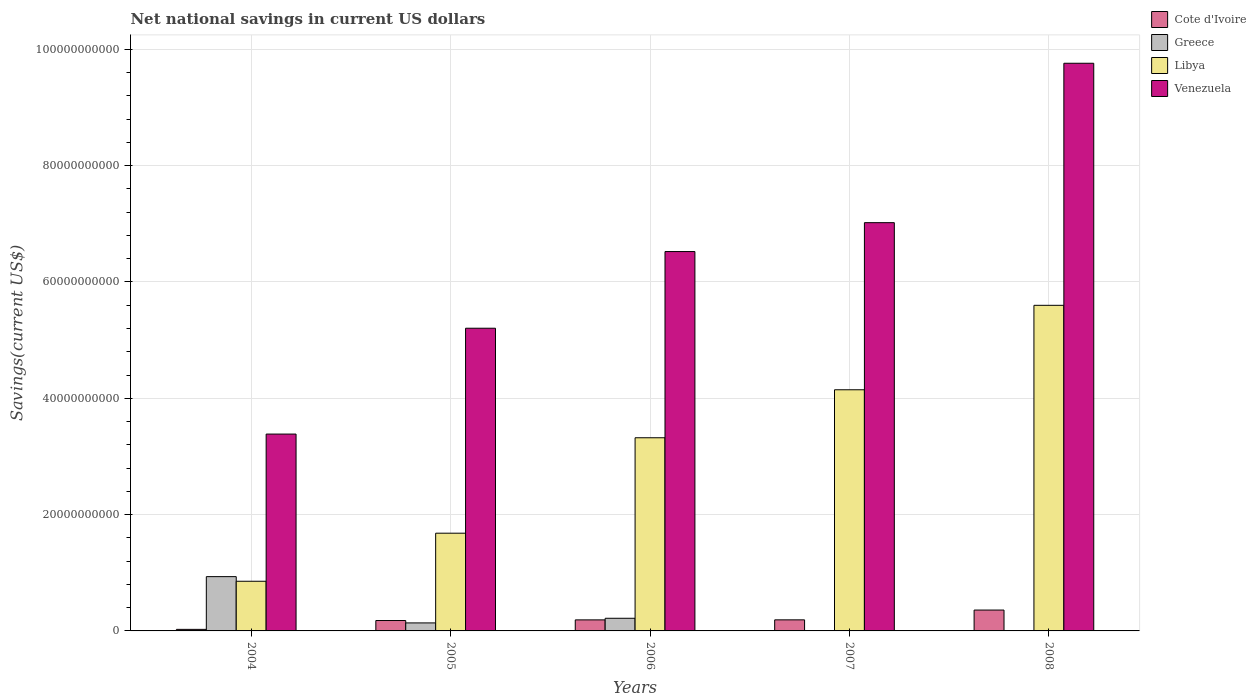How many different coloured bars are there?
Keep it short and to the point. 4. How many groups of bars are there?
Your answer should be very brief. 5. Are the number of bars per tick equal to the number of legend labels?
Keep it short and to the point. No. How many bars are there on the 4th tick from the left?
Offer a very short reply. 3. How many bars are there on the 4th tick from the right?
Your answer should be very brief. 4. What is the net national savings in Venezuela in 2007?
Keep it short and to the point. 7.02e+1. Across all years, what is the maximum net national savings in Greece?
Offer a terse response. 9.34e+09. Across all years, what is the minimum net national savings in Cote d'Ivoire?
Give a very brief answer. 2.67e+08. What is the total net national savings in Greece in the graph?
Ensure brevity in your answer.  1.29e+1. What is the difference between the net national savings in Libya in 2005 and that in 2006?
Provide a short and direct response. -1.64e+1. What is the difference between the net national savings in Venezuela in 2007 and the net national savings in Greece in 2005?
Provide a succinct answer. 6.88e+1. What is the average net national savings in Venezuela per year?
Make the answer very short. 6.38e+1. In the year 2007, what is the difference between the net national savings in Libya and net national savings in Cote d'Ivoire?
Keep it short and to the point. 3.96e+1. In how many years, is the net national savings in Greece greater than 52000000000 US$?
Provide a succinct answer. 0. What is the ratio of the net national savings in Venezuela in 2005 to that in 2008?
Keep it short and to the point. 0.53. Is the net national savings in Libya in 2006 less than that in 2008?
Make the answer very short. Yes. What is the difference between the highest and the second highest net national savings in Greece?
Offer a very short reply. 7.16e+09. What is the difference between the highest and the lowest net national savings in Venezuela?
Your answer should be compact. 6.38e+1. Is the sum of the net national savings in Libya in 2007 and 2008 greater than the maximum net national savings in Cote d'Ivoire across all years?
Provide a short and direct response. Yes. Is it the case that in every year, the sum of the net national savings in Cote d'Ivoire and net national savings in Libya is greater than the sum of net national savings in Greece and net national savings in Venezuela?
Make the answer very short. Yes. Is it the case that in every year, the sum of the net national savings in Libya and net national savings in Greece is greater than the net national savings in Venezuela?
Provide a succinct answer. No. Are all the bars in the graph horizontal?
Keep it short and to the point. No. How many years are there in the graph?
Give a very brief answer. 5. What is the difference between two consecutive major ticks on the Y-axis?
Offer a terse response. 2.00e+1. Are the values on the major ticks of Y-axis written in scientific E-notation?
Provide a short and direct response. No. Does the graph contain any zero values?
Give a very brief answer. Yes. Does the graph contain grids?
Give a very brief answer. Yes. Where does the legend appear in the graph?
Give a very brief answer. Top right. How many legend labels are there?
Provide a short and direct response. 4. What is the title of the graph?
Make the answer very short. Net national savings in current US dollars. What is the label or title of the X-axis?
Your response must be concise. Years. What is the label or title of the Y-axis?
Keep it short and to the point. Savings(current US$). What is the Savings(current US$) in Cote d'Ivoire in 2004?
Give a very brief answer. 2.67e+08. What is the Savings(current US$) in Greece in 2004?
Make the answer very short. 9.34e+09. What is the Savings(current US$) in Libya in 2004?
Provide a short and direct response. 8.54e+09. What is the Savings(current US$) in Venezuela in 2004?
Your response must be concise. 3.39e+1. What is the Savings(current US$) of Cote d'Ivoire in 2005?
Make the answer very short. 1.79e+09. What is the Savings(current US$) of Greece in 2005?
Offer a very short reply. 1.38e+09. What is the Savings(current US$) in Libya in 2005?
Give a very brief answer. 1.68e+1. What is the Savings(current US$) in Venezuela in 2005?
Ensure brevity in your answer.  5.20e+1. What is the Savings(current US$) of Cote d'Ivoire in 2006?
Ensure brevity in your answer.  1.90e+09. What is the Savings(current US$) of Greece in 2006?
Provide a succinct answer. 2.17e+09. What is the Savings(current US$) in Libya in 2006?
Your answer should be very brief. 3.32e+1. What is the Savings(current US$) in Venezuela in 2006?
Provide a succinct answer. 6.52e+1. What is the Savings(current US$) of Cote d'Ivoire in 2007?
Your answer should be very brief. 1.90e+09. What is the Savings(current US$) of Libya in 2007?
Provide a short and direct response. 4.15e+1. What is the Savings(current US$) in Venezuela in 2007?
Your answer should be compact. 7.02e+1. What is the Savings(current US$) of Cote d'Ivoire in 2008?
Give a very brief answer. 3.59e+09. What is the Savings(current US$) in Libya in 2008?
Your answer should be compact. 5.60e+1. What is the Savings(current US$) in Venezuela in 2008?
Provide a succinct answer. 9.76e+1. Across all years, what is the maximum Savings(current US$) of Cote d'Ivoire?
Provide a short and direct response. 3.59e+09. Across all years, what is the maximum Savings(current US$) in Greece?
Ensure brevity in your answer.  9.34e+09. Across all years, what is the maximum Savings(current US$) in Libya?
Your response must be concise. 5.60e+1. Across all years, what is the maximum Savings(current US$) in Venezuela?
Offer a very short reply. 9.76e+1. Across all years, what is the minimum Savings(current US$) of Cote d'Ivoire?
Offer a very short reply. 2.67e+08. Across all years, what is the minimum Savings(current US$) in Libya?
Make the answer very short. 8.54e+09. Across all years, what is the minimum Savings(current US$) in Venezuela?
Your response must be concise. 3.39e+1. What is the total Savings(current US$) in Cote d'Ivoire in the graph?
Your answer should be very brief. 9.45e+09. What is the total Savings(current US$) of Greece in the graph?
Ensure brevity in your answer.  1.29e+1. What is the total Savings(current US$) of Libya in the graph?
Provide a short and direct response. 1.56e+11. What is the total Savings(current US$) of Venezuela in the graph?
Keep it short and to the point. 3.19e+11. What is the difference between the Savings(current US$) in Cote d'Ivoire in 2004 and that in 2005?
Provide a succinct answer. -1.52e+09. What is the difference between the Savings(current US$) of Greece in 2004 and that in 2005?
Provide a succinct answer. 7.96e+09. What is the difference between the Savings(current US$) in Libya in 2004 and that in 2005?
Offer a terse response. -8.26e+09. What is the difference between the Savings(current US$) in Venezuela in 2004 and that in 2005?
Ensure brevity in your answer.  -1.82e+1. What is the difference between the Savings(current US$) of Cote d'Ivoire in 2004 and that in 2006?
Provide a succinct answer. -1.63e+09. What is the difference between the Savings(current US$) in Greece in 2004 and that in 2006?
Give a very brief answer. 7.16e+09. What is the difference between the Savings(current US$) of Libya in 2004 and that in 2006?
Provide a succinct answer. -2.47e+1. What is the difference between the Savings(current US$) of Venezuela in 2004 and that in 2006?
Offer a terse response. -3.14e+1. What is the difference between the Savings(current US$) in Cote d'Ivoire in 2004 and that in 2007?
Provide a succinct answer. -1.64e+09. What is the difference between the Savings(current US$) in Libya in 2004 and that in 2007?
Give a very brief answer. -3.29e+1. What is the difference between the Savings(current US$) of Venezuela in 2004 and that in 2007?
Offer a very short reply. -3.64e+1. What is the difference between the Savings(current US$) in Cote d'Ivoire in 2004 and that in 2008?
Your answer should be very brief. -3.32e+09. What is the difference between the Savings(current US$) of Libya in 2004 and that in 2008?
Offer a terse response. -4.74e+1. What is the difference between the Savings(current US$) in Venezuela in 2004 and that in 2008?
Offer a terse response. -6.38e+1. What is the difference between the Savings(current US$) in Cote d'Ivoire in 2005 and that in 2006?
Provide a short and direct response. -1.12e+08. What is the difference between the Savings(current US$) of Greece in 2005 and that in 2006?
Keep it short and to the point. -7.96e+08. What is the difference between the Savings(current US$) in Libya in 2005 and that in 2006?
Make the answer very short. -1.64e+1. What is the difference between the Savings(current US$) of Venezuela in 2005 and that in 2006?
Give a very brief answer. -1.32e+1. What is the difference between the Savings(current US$) in Cote d'Ivoire in 2005 and that in 2007?
Offer a terse response. -1.17e+08. What is the difference between the Savings(current US$) in Libya in 2005 and that in 2007?
Your answer should be compact. -2.47e+1. What is the difference between the Savings(current US$) in Venezuela in 2005 and that in 2007?
Give a very brief answer. -1.82e+1. What is the difference between the Savings(current US$) in Cote d'Ivoire in 2005 and that in 2008?
Ensure brevity in your answer.  -1.80e+09. What is the difference between the Savings(current US$) in Libya in 2005 and that in 2008?
Your answer should be very brief. -3.92e+1. What is the difference between the Savings(current US$) in Venezuela in 2005 and that in 2008?
Keep it short and to the point. -4.56e+1. What is the difference between the Savings(current US$) of Cote d'Ivoire in 2006 and that in 2007?
Provide a succinct answer. -4.95e+06. What is the difference between the Savings(current US$) in Libya in 2006 and that in 2007?
Your answer should be very brief. -8.25e+09. What is the difference between the Savings(current US$) in Venezuela in 2006 and that in 2007?
Offer a terse response. -4.97e+09. What is the difference between the Savings(current US$) in Cote d'Ivoire in 2006 and that in 2008?
Keep it short and to the point. -1.69e+09. What is the difference between the Savings(current US$) of Libya in 2006 and that in 2008?
Provide a short and direct response. -2.28e+1. What is the difference between the Savings(current US$) in Venezuela in 2006 and that in 2008?
Your answer should be very brief. -3.24e+1. What is the difference between the Savings(current US$) of Cote d'Ivoire in 2007 and that in 2008?
Your answer should be very brief. -1.68e+09. What is the difference between the Savings(current US$) of Libya in 2007 and that in 2008?
Make the answer very short. -1.45e+1. What is the difference between the Savings(current US$) in Venezuela in 2007 and that in 2008?
Offer a terse response. -2.74e+1. What is the difference between the Savings(current US$) in Cote d'Ivoire in 2004 and the Savings(current US$) in Greece in 2005?
Offer a terse response. -1.11e+09. What is the difference between the Savings(current US$) of Cote d'Ivoire in 2004 and the Savings(current US$) of Libya in 2005?
Make the answer very short. -1.65e+1. What is the difference between the Savings(current US$) of Cote d'Ivoire in 2004 and the Savings(current US$) of Venezuela in 2005?
Keep it short and to the point. -5.18e+1. What is the difference between the Savings(current US$) in Greece in 2004 and the Savings(current US$) in Libya in 2005?
Make the answer very short. -7.47e+09. What is the difference between the Savings(current US$) of Greece in 2004 and the Savings(current US$) of Venezuela in 2005?
Provide a succinct answer. -4.27e+1. What is the difference between the Savings(current US$) of Libya in 2004 and the Savings(current US$) of Venezuela in 2005?
Provide a short and direct response. -4.35e+1. What is the difference between the Savings(current US$) in Cote d'Ivoire in 2004 and the Savings(current US$) in Greece in 2006?
Give a very brief answer. -1.91e+09. What is the difference between the Savings(current US$) in Cote d'Ivoire in 2004 and the Savings(current US$) in Libya in 2006?
Your answer should be compact. -3.29e+1. What is the difference between the Savings(current US$) in Cote d'Ivoire in 2004 and the Savings(current US$) in Venezuela in 2006?
Provide a short and direct response. -6.50e+1. What is the difference between the Savings(current US$) in Greece in 2004 and the Savings(current US$) in Libya in 2006?
Offer a terse response. -2.39e+1. What is the difference between the Savings(current US$) of Greece in 2004 and the Savings(current US$) of Venezuela in 2006?
Your answer should be compact. -5.59e+1. What is the difference between the Savings(current US$) in Libya in 2004 and the Savings(current US$) in Venezuela in 2006?
Make the answer very short. -5.67e+1. What is the difference between the Savings(current US$) in Cote d'Ivoire in 2004 and the Savings(current US$) in Libya in 2007?
Provide a succinct answer. -4.12e+1. What is the difference between the Savings(current US$) of Cote d'Ivoire in 2004 and the Savings(current US$) of Venezuela in 2007?
Ensure brevity in your answer.  -6.99e+1. What is the difference between the Savings(current US$) in Greece in 2004 and the Savings(current US$) in Libya in 2007?
Your answer should be very brief. -3.21e+1. What is the difference between the Savings(current US$) in Greece in 2004 and the Savings(current US$) in Venezuela in 2007?
Give a very brief answer. -6.09e+1. What is the difference between the Savings(current US$) of Libya in 2004 and the Savings(current US$) of Venezuela in 2007?
Offer a very short reply. -6.17e+1. What is the difference between the Savings(current US$) of Cote d'Ivoire in 2004 and the Savings(current US$) of Libya in 2008?
Provide a succinct answer. -5.57e+1. What is the difference between the Savings(current US$) of Cote d'Ivoire in 2004 and the Savings(current US$) of Venezuela in 2008?
Your answer should be very brief. -9.73e+1. What is the difference between the Savings(current US$) in Greece in 2004 and the Savings(current US$) in Libya in 2008?
Provide a succinct answer. -4.67e+1. What is the difference between the Savings(current US$) in Greece in 2004 and the Savings(current US$) in Venezuela in 2008?
Your answer should be compact. -8.83e+1. What is the difference between the Savings(current US$) of Libya in 2004 and the Savings(current US$) of Venezuela in 2008?
Offer a very short reply. -8.91e+1. What is the difference between the Savings(current US$) in Cote d'Ivoire in 2005 and the Savings(current US$) in Greece in 2006?
Give a very brief answer. -3.87e+08. What is the difference between the Savings(current US$) in Cote d'Ivoire in 2005 and the Savings(current US$) in Libya in 2006?
Keep it short and to the point. -3.14e+1. What is the difference between the Savings(current US$) of Cote d'Ivoire in 2005 and the Savings(current US$) of Venezuela in 2006?
Your response must be concise. -6.34e+1. What is the difference between the Savings(current US$) in Greece in 2005 and the Savings(current US$) in Libya in 2006?
Provide a short and direct response. -3.18e+1. What is the difference between the Savings(current US$) of Greece in 2005 and the Savings(current US$) of Venezuela in 2006?
Offer a terse response. -6.39e+1. What is the difference between the Savings(current US$) of Libya in 2005 and the Savings(current US$) of Venezuela in 2006?
Your answer should be very brief. -4.84e+1. What is the difference between the Savings(current US$) in Cote d'Ivoire in 2005 and the Savings(current US$) in Libya in 2007?
Ensure brevity in your answer.  -3.97e+1. What is the difference between the Savings(current US$) of Cote d'Ivoire in 2005 and the Savings(current US$) of Venezuela in 2007?
Give a very brief answer. -6.84e+1. What is the difference between the Savings(current US$) of Greece in 2005 and the Savings(current US$) of Libya in 2007?
Your answer should be very brief. -4.01e+1. What is the difference between the Savings(current US$) of Greece in 2005 and the Savings(current US$) of Venezuela in 2007?
Make the answer very short. -6.88e+1. What is the difference between the Savings(current US$) in Libya in 2005 and the Savings(current US$) in Venezuela in 2007?
Give a very brief answer. -5.34e+1. What is the difference between the Savings(current US$) in Cote d'Ivoire in 2005 and the Savings(current US$) in Libya in 2008?
Ensure brevity in your answer.  -5.42e+1. What is the difference between the Savings(current US$) of Cote d'Ivoire in 2005 and the Savings(current US$) of Venezuela in 2008?
Offer a terse response. -9.58e+1. What is the difference between the Savings(current US$) in Greece in 2005 and the Savings(current US$) in Libya in 2008?
Provide a succinct answer. -5.46e+1. What is the difference between the Savings(current US$) of Greece in 2005 and the Savings(current US$) of Venezuela in 2008?
Your answer should be very brief. -9.62e+1. What is the difference between the Savings(current US$) in Libya in 2005 and the Savings(current US$) in Venezuela in 2008?
Offer a terse response. -8.08e+1. What is the difference between the Savings(current US$) in Cote d'Ivoire in 2006 and the Savings(current US$) in Libya in 2007?
Your answer should be compact. -3.96e+1. What is the difference between the Savings(current US$) in Cote d'Ivoire in 2006 and the Savings(current US$) in Venezuela in 2007?
Keep it short and to the point. -6.83e+1. What is the difference between the Savings(current US$) in Greece in 2006 and the Savings(current US$) in Libya in 2007?
Give a very brief answer. -3.93e+1. What is the difference between the Savings(current US$) of Greece in 2006 and the Savings(current US$) of Venezuela in 2007?
Provide a short and direct response. -6.80e+1. What is the difference between the Savings(current US$) in Libya in 2006 and the Savings(current US$) in Venezuela in 2007?
Ensure brevity in your answer.  -3.70e+1. What is the difference between the Savings(current US$) in Cote d'Ivoire in 2006 and the Savings(current US$) in Libya in 2008?
Provide a short and direct response. -5.41e+1. What is the difference between the Savings(current US$) of Cote d'Ivoire in 2006 and the Savings(current US$) of Venezuela in 2008?
Your answer should be very brief. -9.57e+1. What is the difference between the Savings(current US$) in Greece in 2006 and the Savings(current US$) in Libya in 2008?
Provide a succinct answer. -5.38e+1. What is the difference between the Savings(current US$) of Greece in 2006 and the Savings(current US$) of Venezuela in 2008?
Provide a succinct answer. -9.54e+1. What is the difference between the Savings(current US$) in Libya in 2006 and the Savings(current US$) in Venezuela in 2008?
Your answer should be compact. -6.44e+1. What is the difference between the Savings(current US$) of Cote d'Ivoire in 2007 and the Savings(current US$) of Libya in 2008?
Your answer should be very brief. -5.41e+1. What is the difference between the Savings(current US$) of Cote d'Ivoire in 2007 and the Savings(current US$) of Venezuela in 2008?
Your answer should be very brief. -9.57e+1. What is the difference between the Savings(current US$) of Libya in 2007 and the Savings(current US$) of Venezuela in 2008?
Your answer should be compact. -5.61e+1. What is the average Savings(current US$) in Cote d'Ivoire per year?
Give a very brief answer. 1.89e+09. What is the average Savings(current US$) of Greece per year?
Provide a short and direct response. 2.58e+09. What is the average Savings(current US$) of Libya per year?
Ensure brevity in your answer.  3.12e+1. What is the average Savings(current US$) in Venezuela per year?
Your response must be concise. 6.38e+1. In the year 2004, what is the difference between the Savings(current US$) in Cote d'Ivoire and Savings(current US$) in Greece?
Offer a terse response. -9.07e+09. In the year 2004, what is the difference between the Savings(current US$) of Cote d'Ivoire and Savings(current US$) of Libya?
Your answer should be compact. -8.27e+09. In the year 2004, what is the difference between the Savings(current US$) in Cote d'Ivoire and Savings(current US$) in Venezuela?
Offer a terse response. -3.36e+1. In the year 2004, what is the difference between the Savings(current US$) of Greece and Savings(current US$) of Libya?
Make the answer very short. 7.96e+08. In the year 2004, what is the difference between the Savings(current US$) of Greece and Savings(current US$) of Venezuela?
Offer a terse response. -2.45e+1. In the year 2004, what is the difference between the Savings(current US$) in Libya and Savings(current US$) in Venezuela?
Your answer should be very brief. -2.53e+1. In the year 2005, what is the difference between the Savings(current US$) of Cote d'Ivoire and Savings(current US$) of Greece?
Provide a succinct answer. 4.09e+08. In the year 2005, what is the difference between the Savings(current US$) in Cote d'Ivoire and Savings(current US$) in Libya?
Your response must be concise. -1.50e+1. In the year 2005, what is the difference between the Savings(current US$) in Cote d'Ivoire and Savings(current US$) in Venezuela?
Provide a short and direct response. -5.03e+1. In the year 2005, what is the difference between the Savings(current US$) of Greece and Savings(current US$) of Libya?
Your answer should be compact. -1.54e+1. In the year 2005, what is the difference between the Savings(current US$) of Greece and Savings(current US$) of Venezuela?
Keep it short and to the point. -5.07e+1. In the year 2005, what is the difference between the Savings(current US$) in Libya and Savings(current US$) in Venezuela?
Offer a very short reply. -3.52e+1. In the year 2006, what is the difference between the Savings(current US$) in Cote d'Ivoire and Savings(current US$) in Greece?
Your answer should be compact. -2.75e+08. In the year 2006, what is the difference between the Savings(current US$) of Cote d'Ivoire and Savings(current US$) of Libya?
Your response must be concise. -3.13e+1. In the year 2006, what is the difference between the Savings(current US$) in Cote d'Ivoire and Savings(current US$) in Venezuela?
Your answer should be very brief. -6.33e+1. In the year 2006, what is the difference between the Savings(current US$) in Greece and Savings(current US$) in Libya?
Keep it short and to the point. -3.10e+1. In the year 2006, what is the difference between the Savings(current US$) of Greece and Savings(current US$) of Venezuela?
Your response must be concise. -6.31e+1. In the year 2006, what is the difference between the Savings(current US$) in Libya and Savings(current US$) in Venezuela?
Offer a very short reply. -3.20e+1. In the year 2007, what is the difference between the Savings(current US$) in Cote d'Ivoire and Savings(current US$) in Libya?
Offer a very short reply. -3.96e+1. In the year 2007, what is the difference between the Savings(current US$) in Cote d'Ivoire and Savings(current US$) in Venezuela?
Provide a succinct answer. -6.83e+1. In the year 2007, what is the difference between the Savings(current US$) in Libya and Savings(current US$) in Venezuela?
Ensure brevity in your answer.  -2.87e+1. In the year 2008, what is the difference between the Savings(current US$) in Cote d'Ivoire and Savings(current US$) in Libya?
Ensure brevity in your answer.  -5.24e+1. In the year 2008, what is the difference between the Savings(current US$) of Cote d'Ivoire and Savings(current US$) of Venezuela?
Your answer should be compact. -9.40e+1. In the year 2008, what is the difference between the Savings(current US$) of Libya and Savings(current US$) of Venezuela?
Provide a short and direct response. -4.16e+1. What is the ratio of the Savings(current US$) of Cote d'Ivoire in 2004 to that in 2005?
Provide a succinct answer. 0.15. What is the ratio of the Savings(current US$) in Greece in 2004 to that in 2005?
Provide a short and direct response. 6.77. What is the ratio of the Savings(current US$) of Libya in 2004 to that in 2005?
Keep it short and to the point. 0.51. What is the ratio of the Savings(current US$) in Venezuela in 2004 to that in 2005?
Your answer should be very brief. 0.65. What is the ratio of the Savings(current US$) in Cote d'Ivoire in 2004 to that in 2006?
Your response must be concise. 0.14. What is the ratio of the Savings(current US$) of Greece in 2004 to that in 2006?
Offer a very short reply. 4.29. What is the ratio of the Savings(current US$) of Libya in 2004 to that in 2006?
Provide a succinct answer. 0.26. What is the ratio of the Savings(current US$) in Venezuela in 2004 to that in 2006?
Provide a short and direct response. 0.52. What is the ratio of the Savings(current US$) in Cote d'Ivoire in 2004 to that in 2007?
Your answer should be very brief. 0.14. What is the ratio of the Savings(current US$) of Libya in 2004 to that in 2007?
Give a very brief answer. 0.21. What is the ratio of the Savings(current US$) in Venezuela in 2004 to that in 2007?
Your answer should be compact. 0.48. What is the ratio of the Savings(current US$) in Cote d'Ivoire in 2004 to that in 2008?
Your answer should be compact. 0.07. What is the ratio of the Savings(current US$) of Libya in 2004 to that in 2008?
Make the answer very short. 0.15. What is the ratio of the Savings(current US$) in Venezuela in 2004 to that in 2008?
Offer a terse response. 0.35. What is the ratio of the Savings(current US$) of Cote d'Ivoire in 2005 to that in 2006?
Provide a short and direct response. 0.94. What is the ratio of the Savings(current US$) in Greece in 2005 to that in 2006?
Keep it short and to the point. 0.63. What is the ratio of the Savings(current US$) of Libya in 2005 to that in 2006?
Offer a terse response. 0.51. What is the ratio of the Savings(current US$) in Venezuela in 2005 to that in 2006?
Make the answer very short. 0.8. What is the ratio of the Savings(current US$) of Cote d'Ivoire in 2005 to that in 2007?
Your answer should be very brief. 0.94. What is the ratio of the Savings(current US$) in Libya in 2005 to that in 2007?
Provide a short and direct response. 0.41. What is the ratio of the Savings(current US$) in Venezuela in 2005 to that in 2007?
Keep it short and to the point. 0.74. What is the ratio of the Savings(current US$) in Cote d'Ivoire in 2005 to that in 2008?
Provide a short and direct response. 0.5. What is the ratio of the Savings(current US$) of Libya in 2005 to that in 2008?
Make the answer very short. 0.3. What is the ratio of the Savings(current US$) in Venezuela in 2005 to that in 2008?
Give a very brief answer. 0.53. What is the ratio of the Savings(current US$) in Libya in 2006 to that in 2007?
Keep it short and to the point. 0.8. What is the ratio of the Savings(current US$) of Venezuela in 2006 to that in 2007?
Your answer should be compact. 0.93. What is the ratio of the Savings(current US$) of Cote d'Ivoire in 2006 to that in 2008?
Your answer should be very brief. 0.53. What is the ratio of the Savings(current US$) in Libya in 2006 to that in 2008?
Offer a very short reply. 0.59. What is the ratio of the Savings(current US$) of Venezuela in 2006 to that in 2008?
Your answer should be very brief. 0.67. What is the ratio of the Savings(current US$) in Cote d'Ivoire in 2007 to that in 2008?
Ensure brevity in your answer.  0.53. What is the ratio of the Savings(current US$) in Libya in 2007 to that in 2008?
Make the answer very short. 0.74. What is the ratio of the Savings(current US$) in Venezuela in 2007 to that in 2008?
Provide a succinct answer. 0.72. What is the difference between the highest and the second highest Savings(current US$) of Cote d'Ivoire?
Make the answer very short. 1.68e+09. What is the difference between the highest and the second highest Savings(current US$) in Greece?
Your answer should be compact. 7.16e+09. What is the difference between the highest and the second highest Savings(current US$) of Libya?
Make the answer very short. 1.45e+1. What is the difference between the highest and the second highest Savings(current US$) of Venezuela?
Keep it short and to the point. 2.74e+1. What is the difference between the highest and the lowest Savings(current US$) of Cote d'Ivoire?
Your answer should be compact. 3.32e+09. What is the difference between the highest and the lowest Savings(current US$) in Greece?
Offer a very short reply. 9.34e+09. What is the difference between the highest and the lowest Savings(current US$) of Libya?
Your answer should be very brief. 4.74e+1. What is the difference between the highest and the lowest Savings(current US$) in Venezuela?
Offer a very short reply. 6.38e+1. 